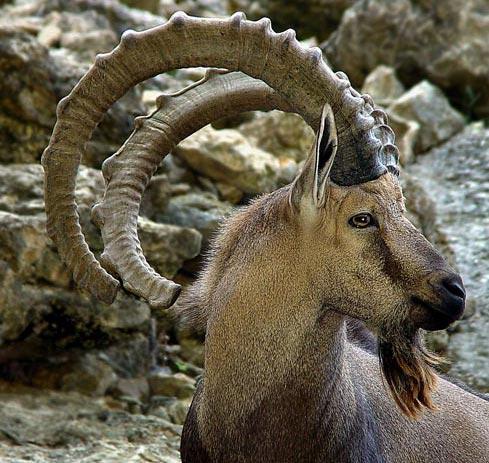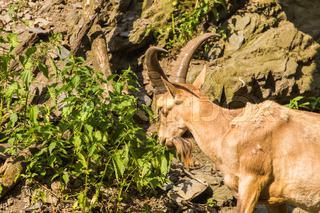The first image is the image on the left, the second image is the image on the right. Considering the images on both sides, is "exactly one goat is in the image to the right, eating grass." valid? Answer yes or no. Yes. The first image is the image on the left, the second image is the image on the right. Assess this claim about the two images: "An image contains at least two hooved animals in an area with green foliage, with at least one animal upright on all fours.". Correct or not? Answer yes or no. No. 